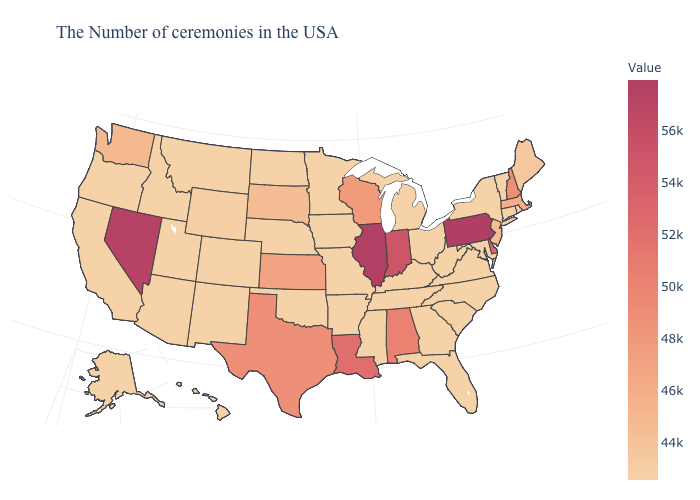Which states have the lowest value in the USA?
Short answer required. Rhode Island, Vermont, Connecticut, New York, Maryland, Virginia, North Carolina, South Carolina, Ohio, Florida, Georgia, Michigan, Kentucky, Tennessee, Mississippi, Missouri, Arkansas, Minnesota, Iowa, Nebraska, Oklahoma, North Dakota, Colorado, New Mexico, Utah, Montana, Arizona, Idaho, California, Oregon, Alaska, Hawaii. Which states have the highest value in the USA?
Keep it brief. Pennsylvania. Which states have the lowest value in the USA?
Be succinct. Rhode Island, Vermont, Connecticut, New York, Maryland, Virginia, North Carolina, South Carolina, Ohio, Florida, Georgia, Michigan, Kentucky, Tennessee, Mississippi, Missouri, Arkansas, Minnesota, Iowa, Nebraska, Oklahoma, North Dakota, Colorado, New Mexico, Utah, Montana, Arizona, Idaho, California, Oregon, Alaska, Hawaii. Among the states that border New Hampshire , does Massachusetts have the highest value?
Write a very short answer. Yes. Among the states that border Tennessee , which have the lowest value?
Concise answer only. Virginia, North Carolina, Georgia, Kentucky, Mississippi, Missouri, Arkansas. Which states hav the highest value in the South?
Answer briefly. Delaware. 